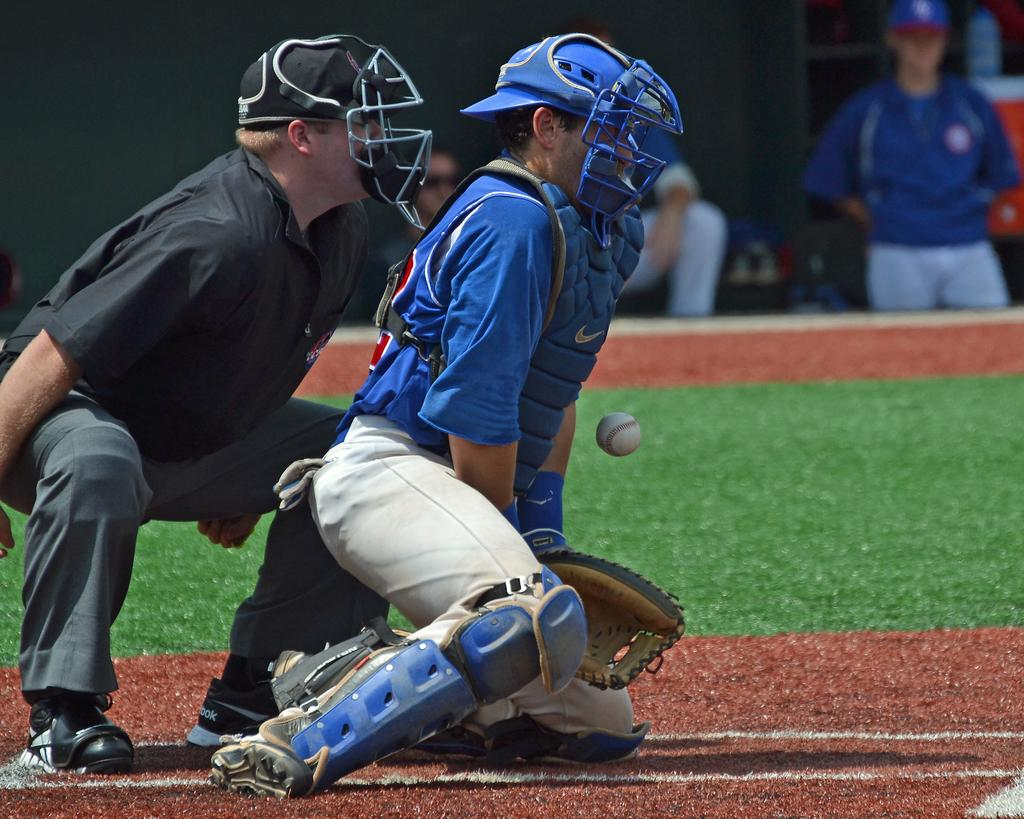What are the two persons in the image doing? The two persons in the image are crouching. What object is in front of the crouching persons? There is a ball in front of the crouching persons. What type of surface is beneath the crouching persons? There is a greenery ground beside the crouching persons. Can you describe the background of the image? There are other persons in the background of the image. What type of joke is the yak telling in the image? There is no yak present in the image, and therefore no joke can be observed. What sound does the alarm make in the image? There is no alarm present in the image, and therefore no sound can be heard. 